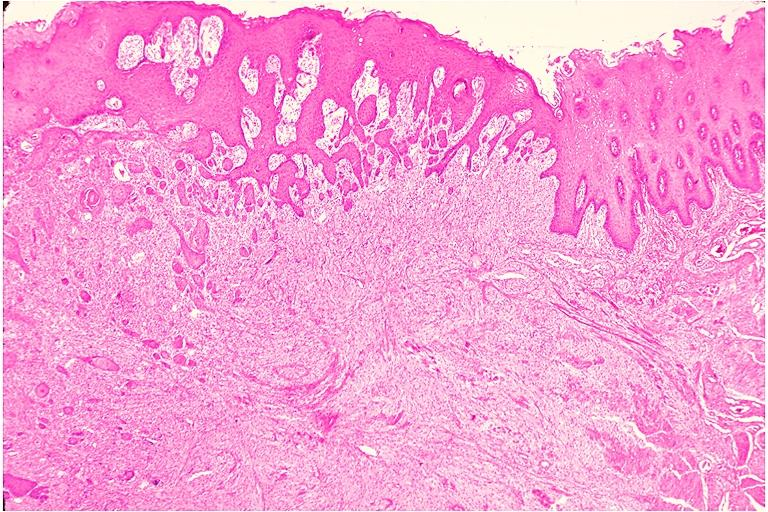what is present?
Answer the question using a single word or phrase. Oral 